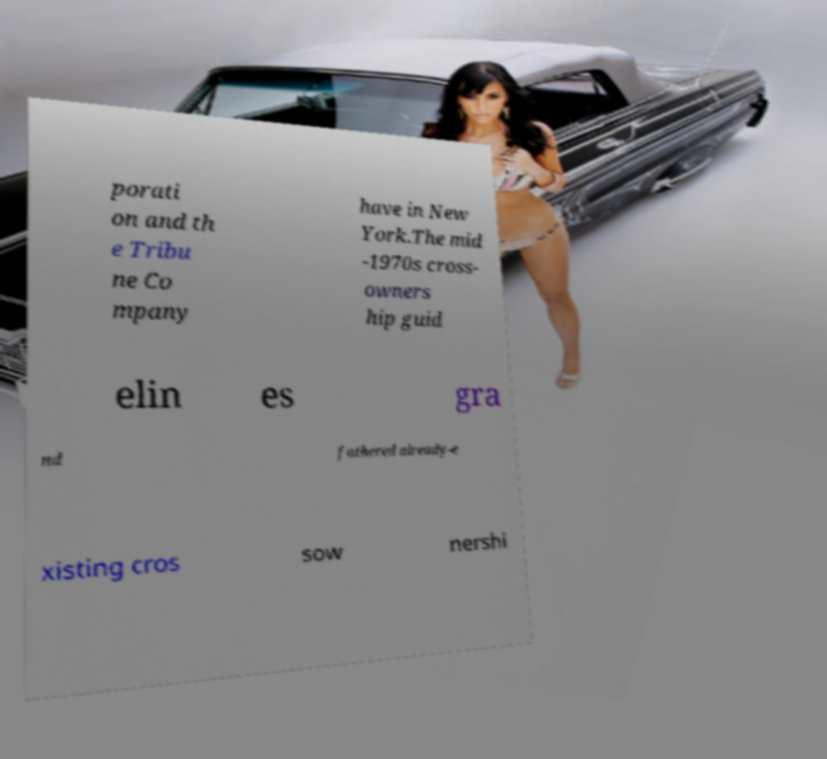Please identify and transcribe the text found in this image. porati on and th e Tribu ne Co mpany have in New York.The mid -1970s cross- owners hip guid elin es gra nd fathered already-e xisting cros sow nershi 